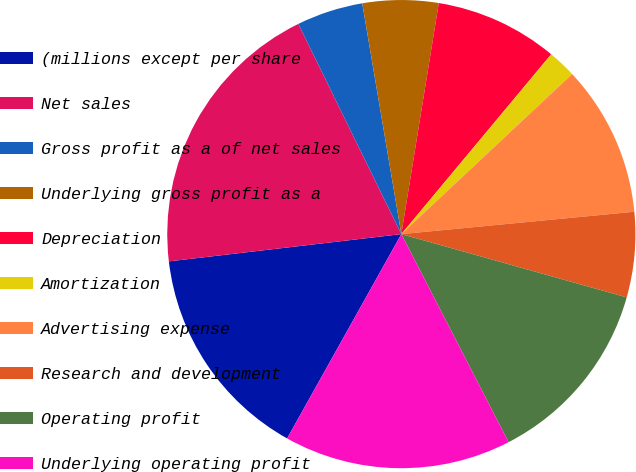Convert chart to OTSL. <chart><loc_0><loc_0><loc_500><loc_500><pie_chart><fcel>(millions except per share<fcel>Net sales<fcel>Gross profit as a of net sales<fcel>Underlying gross profit as a<fcel>Depreciation<fcel>Amortization<fcel>Advertising expense<fcel>Research and development<fcel>Operating profit<fcel>Underlying operating profit<nl><fcel>15.03%<fcel>19.61%<fcel>4.58%<fcel>5.23%<fcel>8.5%<fcel>1.96%<fcel>10.46%<fcel>5.88%<fcel>13.07%<fcel>15.69%<nl></chart> 